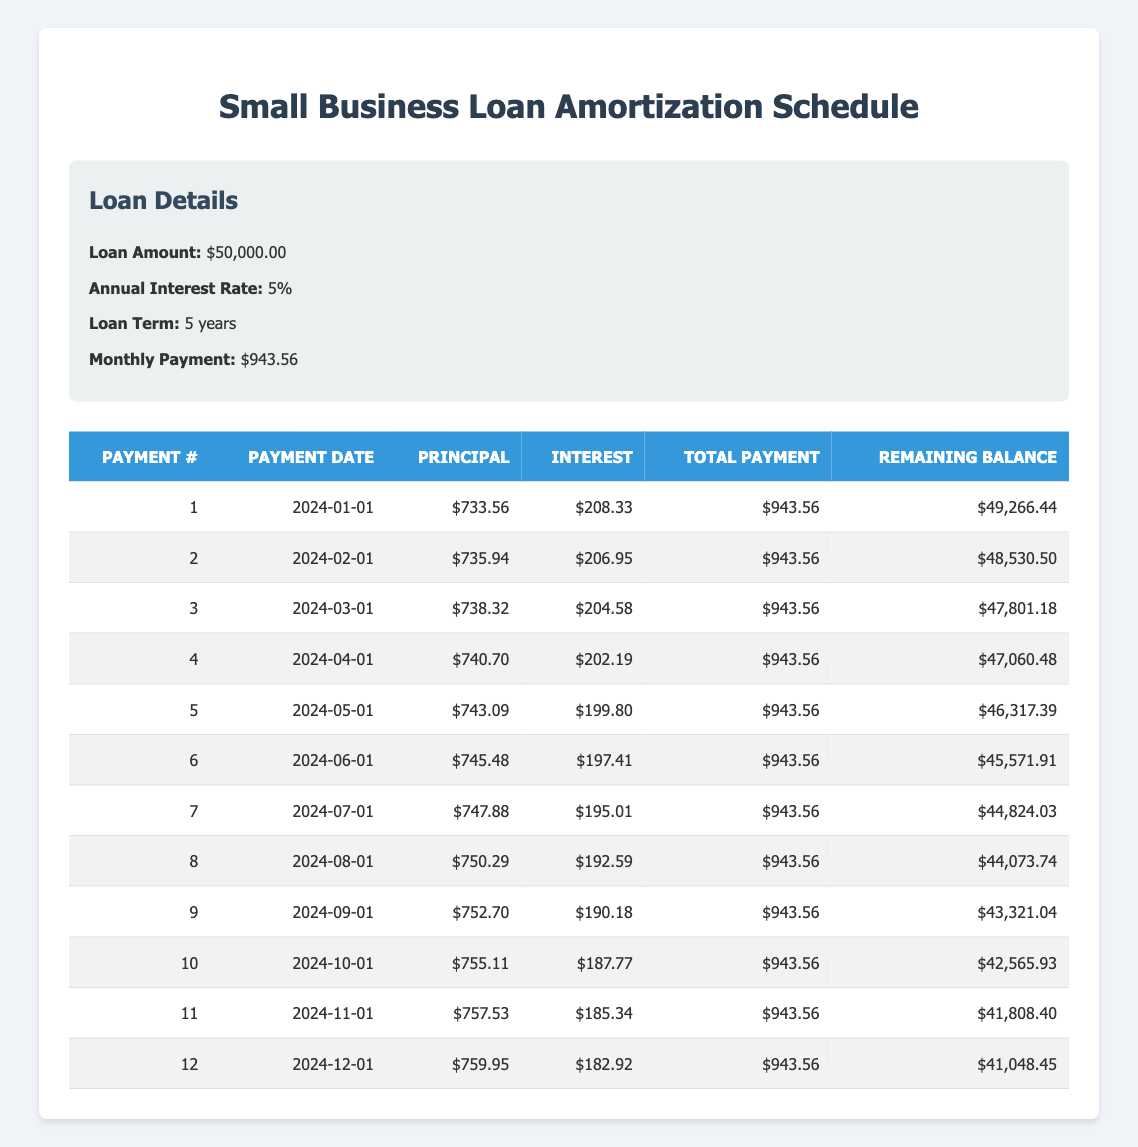What is the total payment amount for the first month? The total payment for the first month is listed in the table under the "Total Payment" column for Payment #1, which is $943.56.
Answer: 943.56 How much of the second payment is applied towards the principal? The principal payment for the second month is found in the "Principal" column for Payment #2, which is $735.94.
Answer: 735.94 What is the remaining balance after the fifth payment? The remaining balance after the fifth payment can be found in the "Remaining Balance" column for Payment #5, which is $46,317.39.
Answer: 46,317.39 Is the interest payment for the second month greater than the interest payment for the first month? The interest payment for the second month is $206.95, and for the first month it is $208.33. Since $206.95 is less than $208.33, the answer is no.
Answer: No What is the average principal payment over the first 12 months? The principal payments for the first 12 months are: 733.56, 735.94, 738.32, 740.70, 743.09, 745.48, 747.88, 750.29, 752.70, 755.11, 757.53, 759.95. The total of these payments is 8,931.56. To find the average, we divide this by 12, giving an average principal payment of 743.63.
Answer: 743.63 How many times does the monthly principal payment exceed $750 during the first 12 payments? Looking through the "Principal" column for each payment, the payments exceeding $750 are Payment #8, Payment #9, Payment #10, Payment #11, and Payment #12. That accounts for 5 instances where the payment exceeds $750.
Answer: 5 What is the total amount of interest paid in the first six months? To find the total interest paid in the first six months, we can add up the interest payments for Payment #1 to Payment #6, which gives us $208.33 + $206.95 + $204.58 + $202.19 + $199.80 + $197.41 = $1,219.26.
Answer: 1,219.26 Is the monthly payment consistent for all 12 payments? Since the "Total Payment" for each month remains constant at $943.56 across all 12 entries in the table, the answer is yes.
Answer: Yes What is the increase in principal payment from the first to the sixth month? The principal payment for the first month is $733.56 and the sixth month is $745.48. The increase can be calculated as $745.48 - $733.56 = $11.92.
Answer: 11.92 